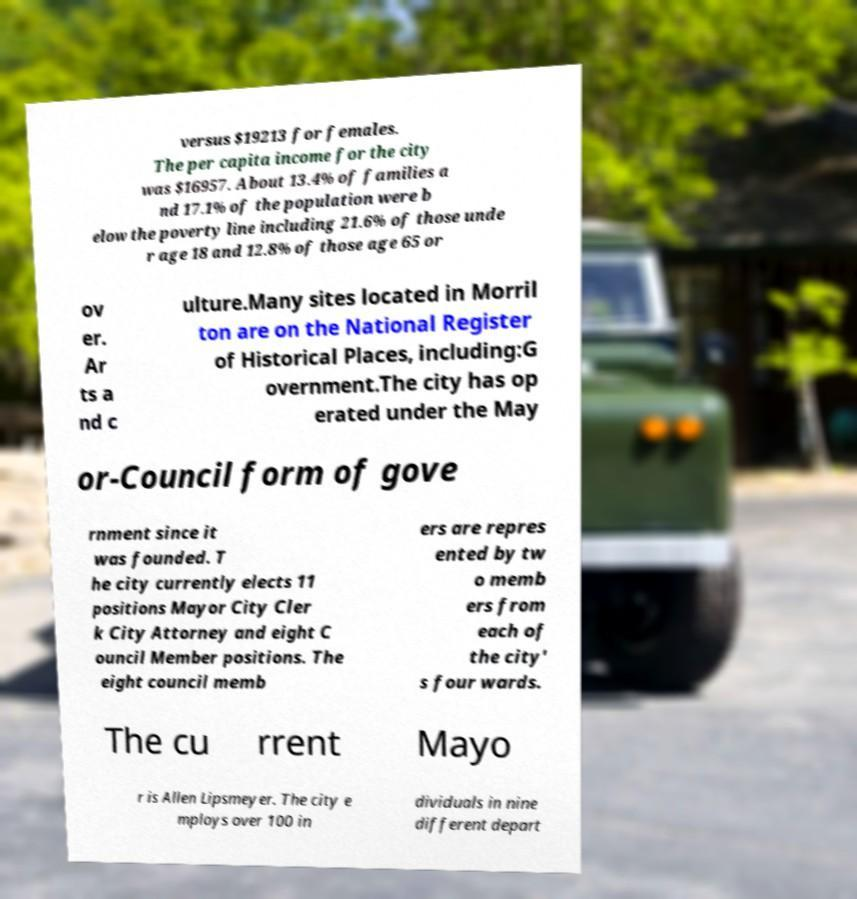Can you accurately transcribe the text from the provided image for me? versus $19213 for females. The per capita income for the city was $16957. About 13.4% of families a nd 17.1% of the population were b elow the poverty line including 21.6% of those unde r age 18 and 12.8% of those age 65 or ov er. Ar ts a nd c ulture.Many sites located in Morril ton are on the National Register of Historical Places, including:G overnment.The city has op erated under the May or-Council form of gove rnment since it was founded. T he city currently elects 11 positions Mayor City Cler k City Attorney and eight C ouncil Member positions. The eight council memb ers are repres ented by tw o memb ers from each of the city' s four wards. The cu rrent Mayo r is Allen Lipsmeyer. The city e mploys over 100 in dividuals in nine different depart 